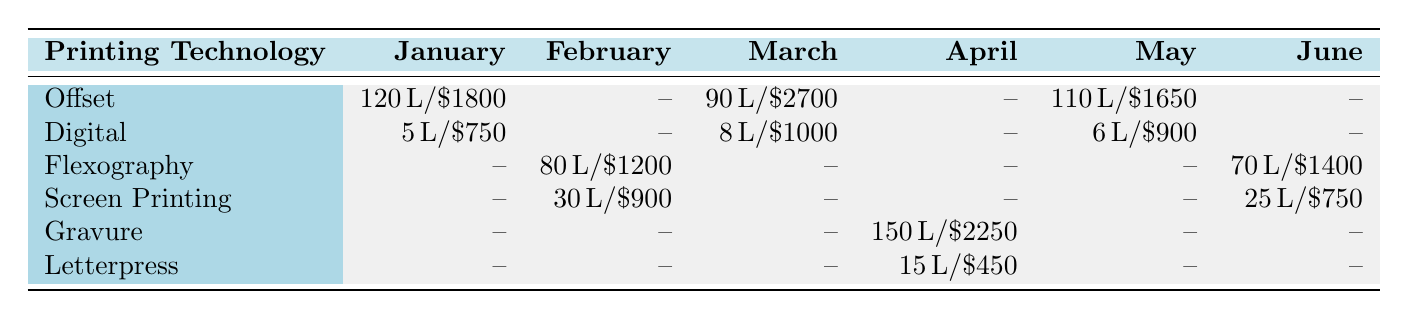What was the ink consumption in liters for Offset printing in March? In March, the table shows that the ink consumption for Offset printing is 90 liters.
Answer: 90 liters What was the total cost for Digital printing across all months? The costs for Digital printing in each month are $750 (January) + $1000 (March) + $900 (May) = $2650.
Answer: $2650 Is there any month with ink consumption for Gravure printing? The table indicates that Gravure printing has ink consumption in April only. Therefore, the answer is yes.
Answer: Yes Which printing technology had the highest ink consumption in April? In April, Gravure printing had an ink consumption of 150 liters, which is higher than the 15 liters of Letterpress.
Answer: Gravure What is the average cost of ink for Screen Printing over the recorded months? The costs for Screen Printing are $900 (February) and $750 (June), totaling $1650 for 2 months. The average cost is $1650 / 2 = $825.
Answer: $825 What is the total ink consumption for the Flexography technology throughout the recorded months? The table shows 80 liters for February and 70 liters for June, adding them gives a total ink consumption of 150 liters for Flexography.
Answer: 150 liters Was there any month where the cost for Digital printing was lower than $800? The table indicates the costs for Digital printing are $750 (January), $1000 (March), and $900 (May). Since $750 is lower than $800, the answer is yes.
Answer: Yes Which month had the highest cost for Offset printing, and what was the amount? The table reveals that March had the highest cost for Offset printing at $2700, which is more than the costs in January and May.
Answer: March, $2700 